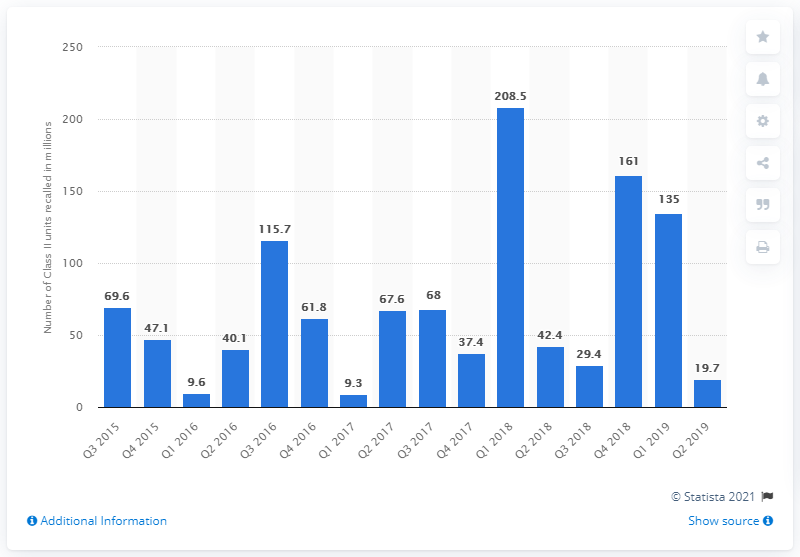Draw attention to some important aspects in this diagram. In the second quarter of 2016, a total of 40.1 medical devices were recalled. 